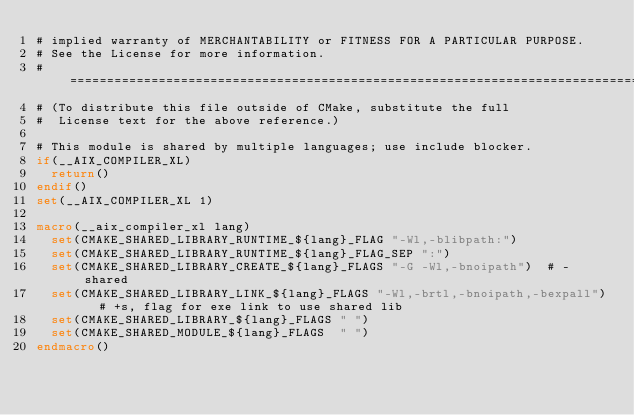<code> <loc_0><loc_0><loc_500><loc_500><_CMake_># implied warranty of MERCHANTABILITY or FITNESS FOR A PARTICULAR PURPOSE.
# See the License for more information.
#=============================================================================
# (To distribute this file outside of CMake, substitute the full
#  License text for the above reference.)

# This module is shared by multiple languages; use include blocker.
if(__AIX_COMPILER_XL)
  return()
endif()
set(__AIX_COMPILER_XL 1)

macro(__aix_compiler_xl lang)
  set(CMAKE_SHARED_LIBRARY_RUNTIME_${lang}_FLAG "-Wl,-blibpath:")
  set(CMAKE_SHARED_LIBRARY_RUNTIME_${lang}_FLAG_SEP ":")
  set(CMAKE_SHARED_LIBRARY_CREATE_${lang}_FLAGS "-G -Wl,-bnoipath")  # -shared
  set(CMAKE_SHARED_LIBRARY_LINK_${lang}_FLAGS "-Wl,-brtl,-bnoipath,-bexpall")  # +s, flag for exe link to use shared lib
  set(CMAKE_SHARED_LIBRARY_${lang}_FLAGS " ")
  set(CMAKE_SHARED_MODULE_${lang}_FLAGS  " ")
endmacro()
</code> 